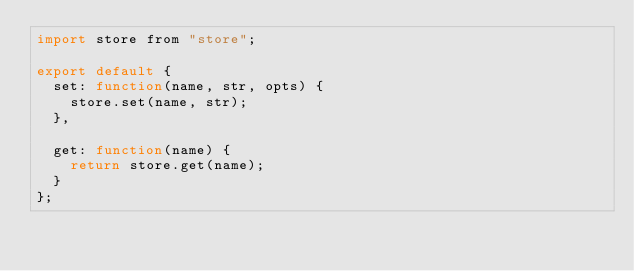Convert code to text. <code><loc_0><loc_0><loc_500><loc_500><_JavaScript_>import store from "store";

export default {
  set: function(name, str, opts) {
    store.set(name, str);
  },

  get: function(name) {
    return store.get(name);
  }
};
</code> 